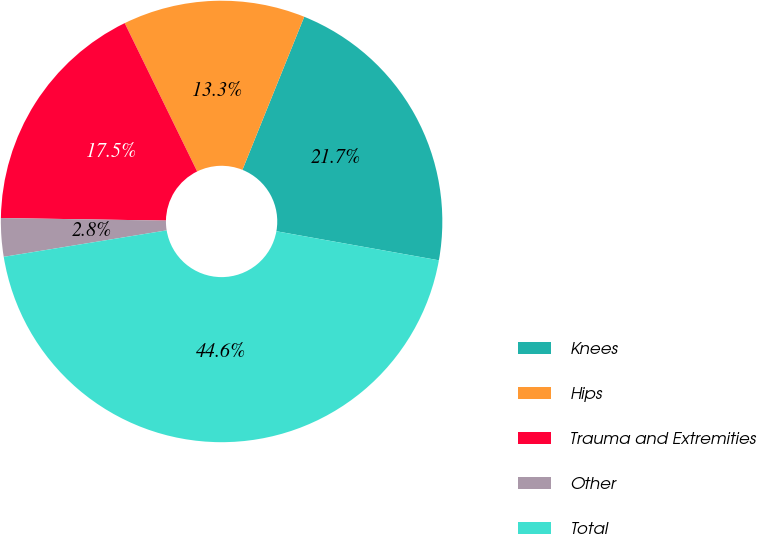<chart> <loc_0><loc_0><loc_500><loc_500><pie_chart><fcel>Knees<fcel>Hips<fcel>Trauma and Extremities<fcel>Other<fcel>Total<nl><fcel>21.71%<fcel>13.34%<fcel>17.52%<fcel>2.81%<fcel>44.62%<nl></chart> 